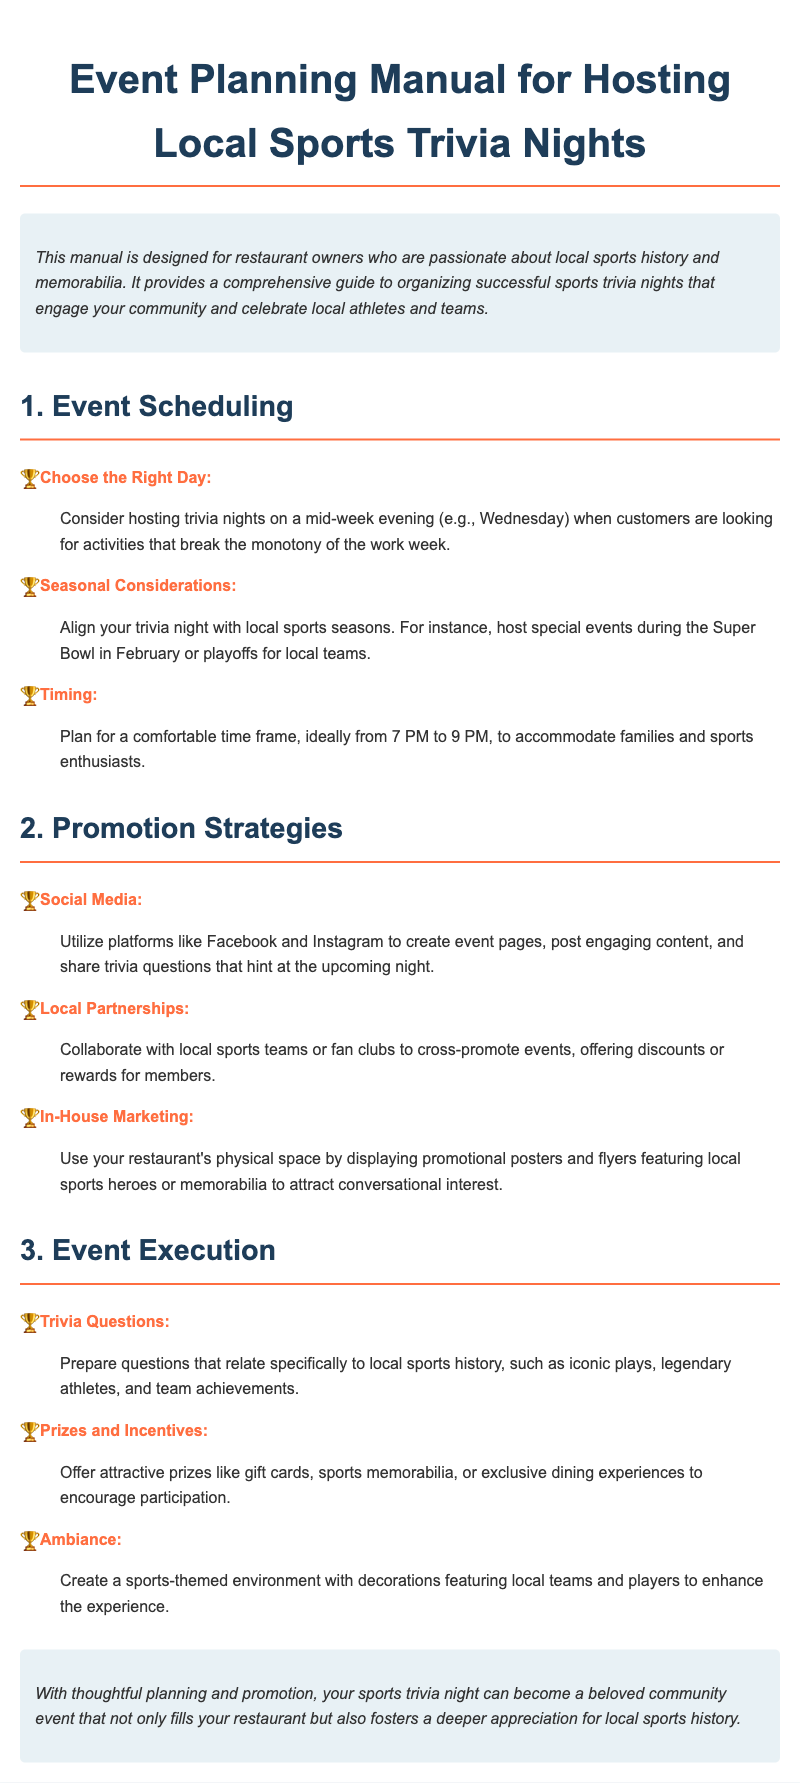what is the ideal time frame for trivia night? The document suggests that the comfortable time frame for trivia night is from 7 PM to 9 PM.
Answer: 7 PM to 9 PM which day is recommended for hosting trivia nights? The manual recommends hosting trivia nights on a mid-week evening, such as Wednesday.
Answer: Wednesday what type of questions should be prepared for trivia night? The recommendation is to prepare questions that relate specifically to local sports history, such as iconic plays, legendary athletes, and team achievements.
Answer: local sports history what is one way to promote events on social media? The document advises utilizing platforms like Facebook and Instagram to create event pages, post engaging content, and share trivia questions.
Answer: create event pages name a recommended prize for participants The manual suggests offering attractive prizes like gift cards, sports memorabilia, or exclusive dining experiences.
Answer: gift cards what is the suggested collaboration for promotion? It is suggested to collaborate with local sports teams or fan clubs to cross-promote events.
Answer: local sports teams which area should have promotional materials displayed? It is recommended to use the restaurant's physical space for displaying promotional posters and flyers.
Answer: restaurant's physical space what ambience should be created for the trivia night? The document recommends creating a sports-themed environment with decorations featuring local teams and players.
Answer: sports-themed environment 